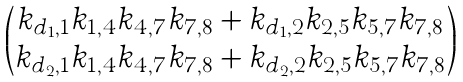Convert formula to latex. <formula><loc_0><loc_0><loc_500><loc_500>\begin{pmatrix} k _ { d _ { 1 } , 1 } k _ { 1 , 4 } k _ { 4 , 7 } k _ { 7 , 8 } + k _ { d _ { 1 } , 2 } k _ { 2 , 5 } k _ { 5 , 7 } k _ { 7 , 8 } \\ k _ { d _ { 2 } , 1 } k _ { 1 , 4 } k _ { 4 , 7 } k _ { 7 , 8 } + k _ { d _ { 2 } , 2 } k _ { 2 , 5 } k _ { 5 , 7 } k _ { 7 , 8 } \end{pmatrix}</formula> 